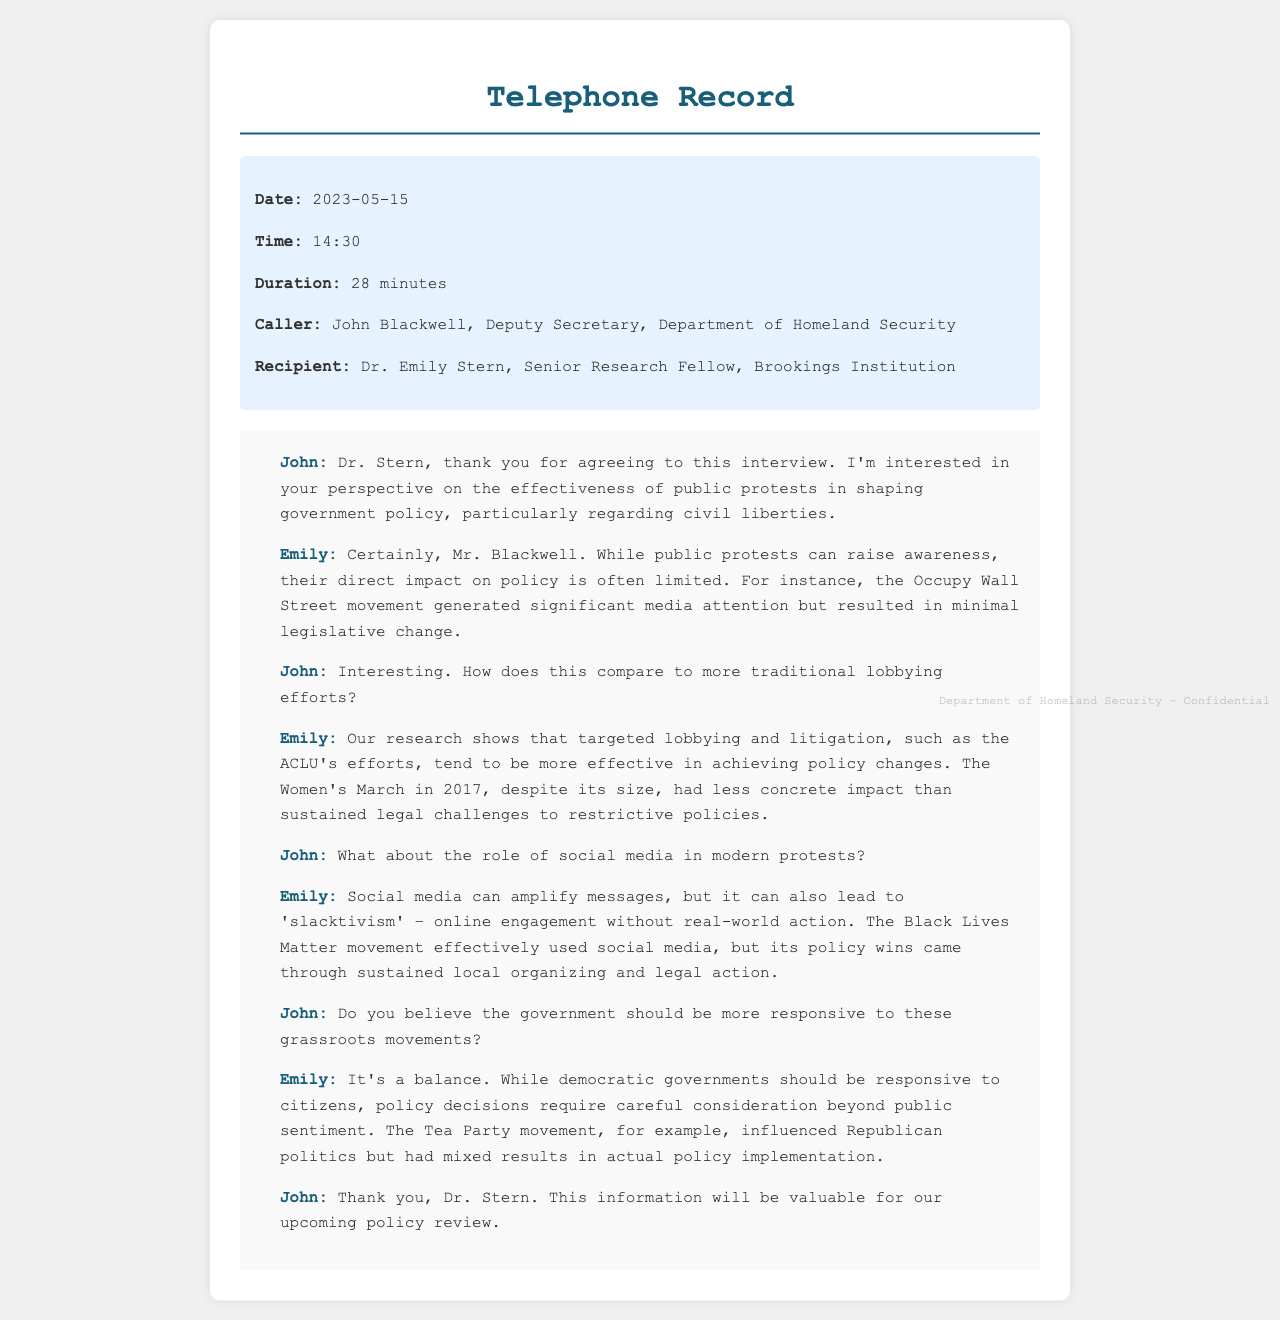what is the date of the call? The date is specified in the call details section of the document.
Answer: 2023-05-15 who is the caller? The caller's name and title are provided in the call details.
Answer: John Blackwell, Deputy Secretary, Department of Homeland Security how long did the call last? The duration of the call is mentioned in the call details section.
Answer: 28 minutes what was the main topic discussed? The main topic is indicated in the introductory line of the dialogue.
Answer: Effectiveness of public protests in shaping government policy what organization did Dr. Emily Stern represent? Dr. Stern's organizational affiliation is stated in the recipient details.
Answer: Brookings Institution what example did Emily give concerning public protests? Emily mentioned specific movements to illustrate her point.
Answer: Occupy Wall Street how does Emily describe the impact of social media? The description of social media's impact is included in her dialogue.
Answer: Amplify messages, but lead to 'slacktivism' what balance does Emily mention regarding government responsiveness? Emily discusses the balance in her explanation of government response.
Answer: Democratic governments should be responsive to citizens what was John’s position in the Department of Homeland Security? John’s title is given in the call details section.
Answer: Deputy Secretary 